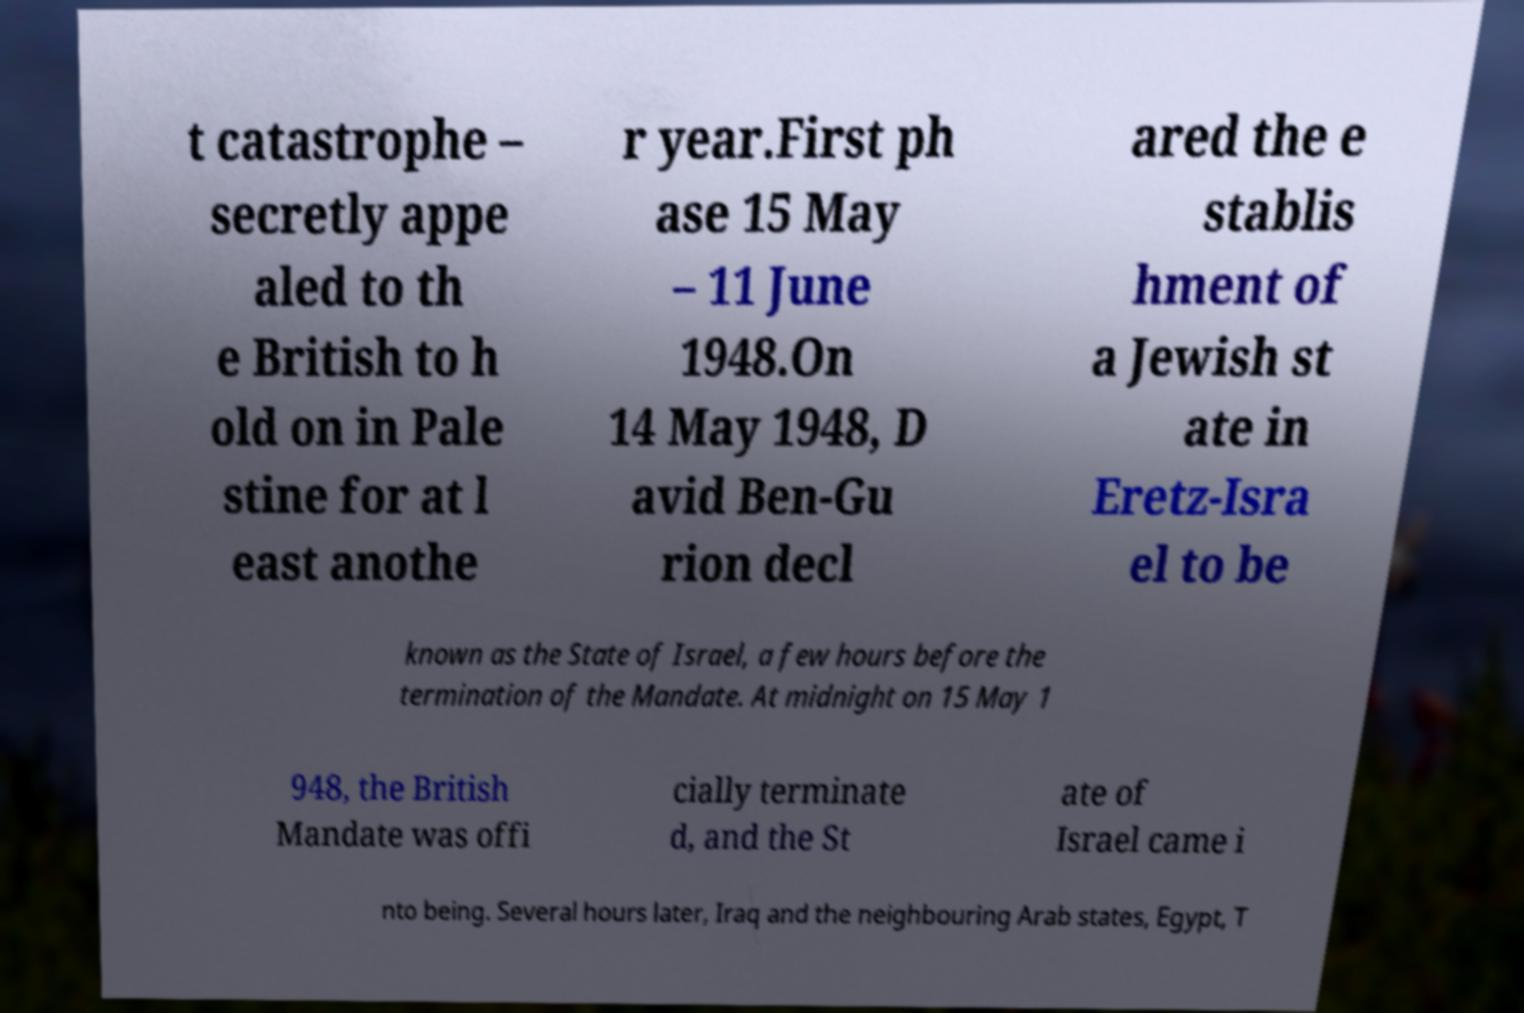What messages or text are displayed in this image? I need them in a readable, typed format. t catastrophe – secretly appe aled to th e British to h old on in Pale stine for at l east anothe r year.First ph ase 15 May – 11 June 1948.On 14 May 1948, D avid Ben-Gu rion decl ared the e stablis hment of a Jewish st ate in Eretz-Isra el to be known as the State of Israel, a few hours before the termination of the Mandate. At midnight on 15 May 1 948, the British Mandate was offi cially terminate d, and the St ate of Israel came i nto being. Several hours later, Iraq and the neighbouring Arab states, Egypt, T 